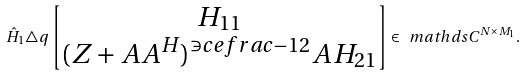Convert formula to latex. <formula><loc_0><loc_0><loc_500><loc_500>\hat { H } _ { 1 } \triangle q \begin{bmatrix} H _ { 1 1 } \\ ( Z + A A ^ { H } ) ^ { \ni c e f r a c { - 1 } { 2 } } A H _ { 2 1 } \end{bmatrix} \in \ m a t h d s { C } ^ { N \times M _ { 1 } } .</formula> 